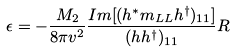Convert formula to latex. <formula><loc_0><loc_0><loc_500><loc_500>\epsilon = - \frac { M _ { 2 } } { 8 \pi v ^ { 2 } } \frac { I m [ ( h ^ { \ast } m _ { L L } h ^ { \dag } ) _ { 1 1 } ] } { ( h h ^ { \dag } ) _ { 1 1 } } R</formula> 